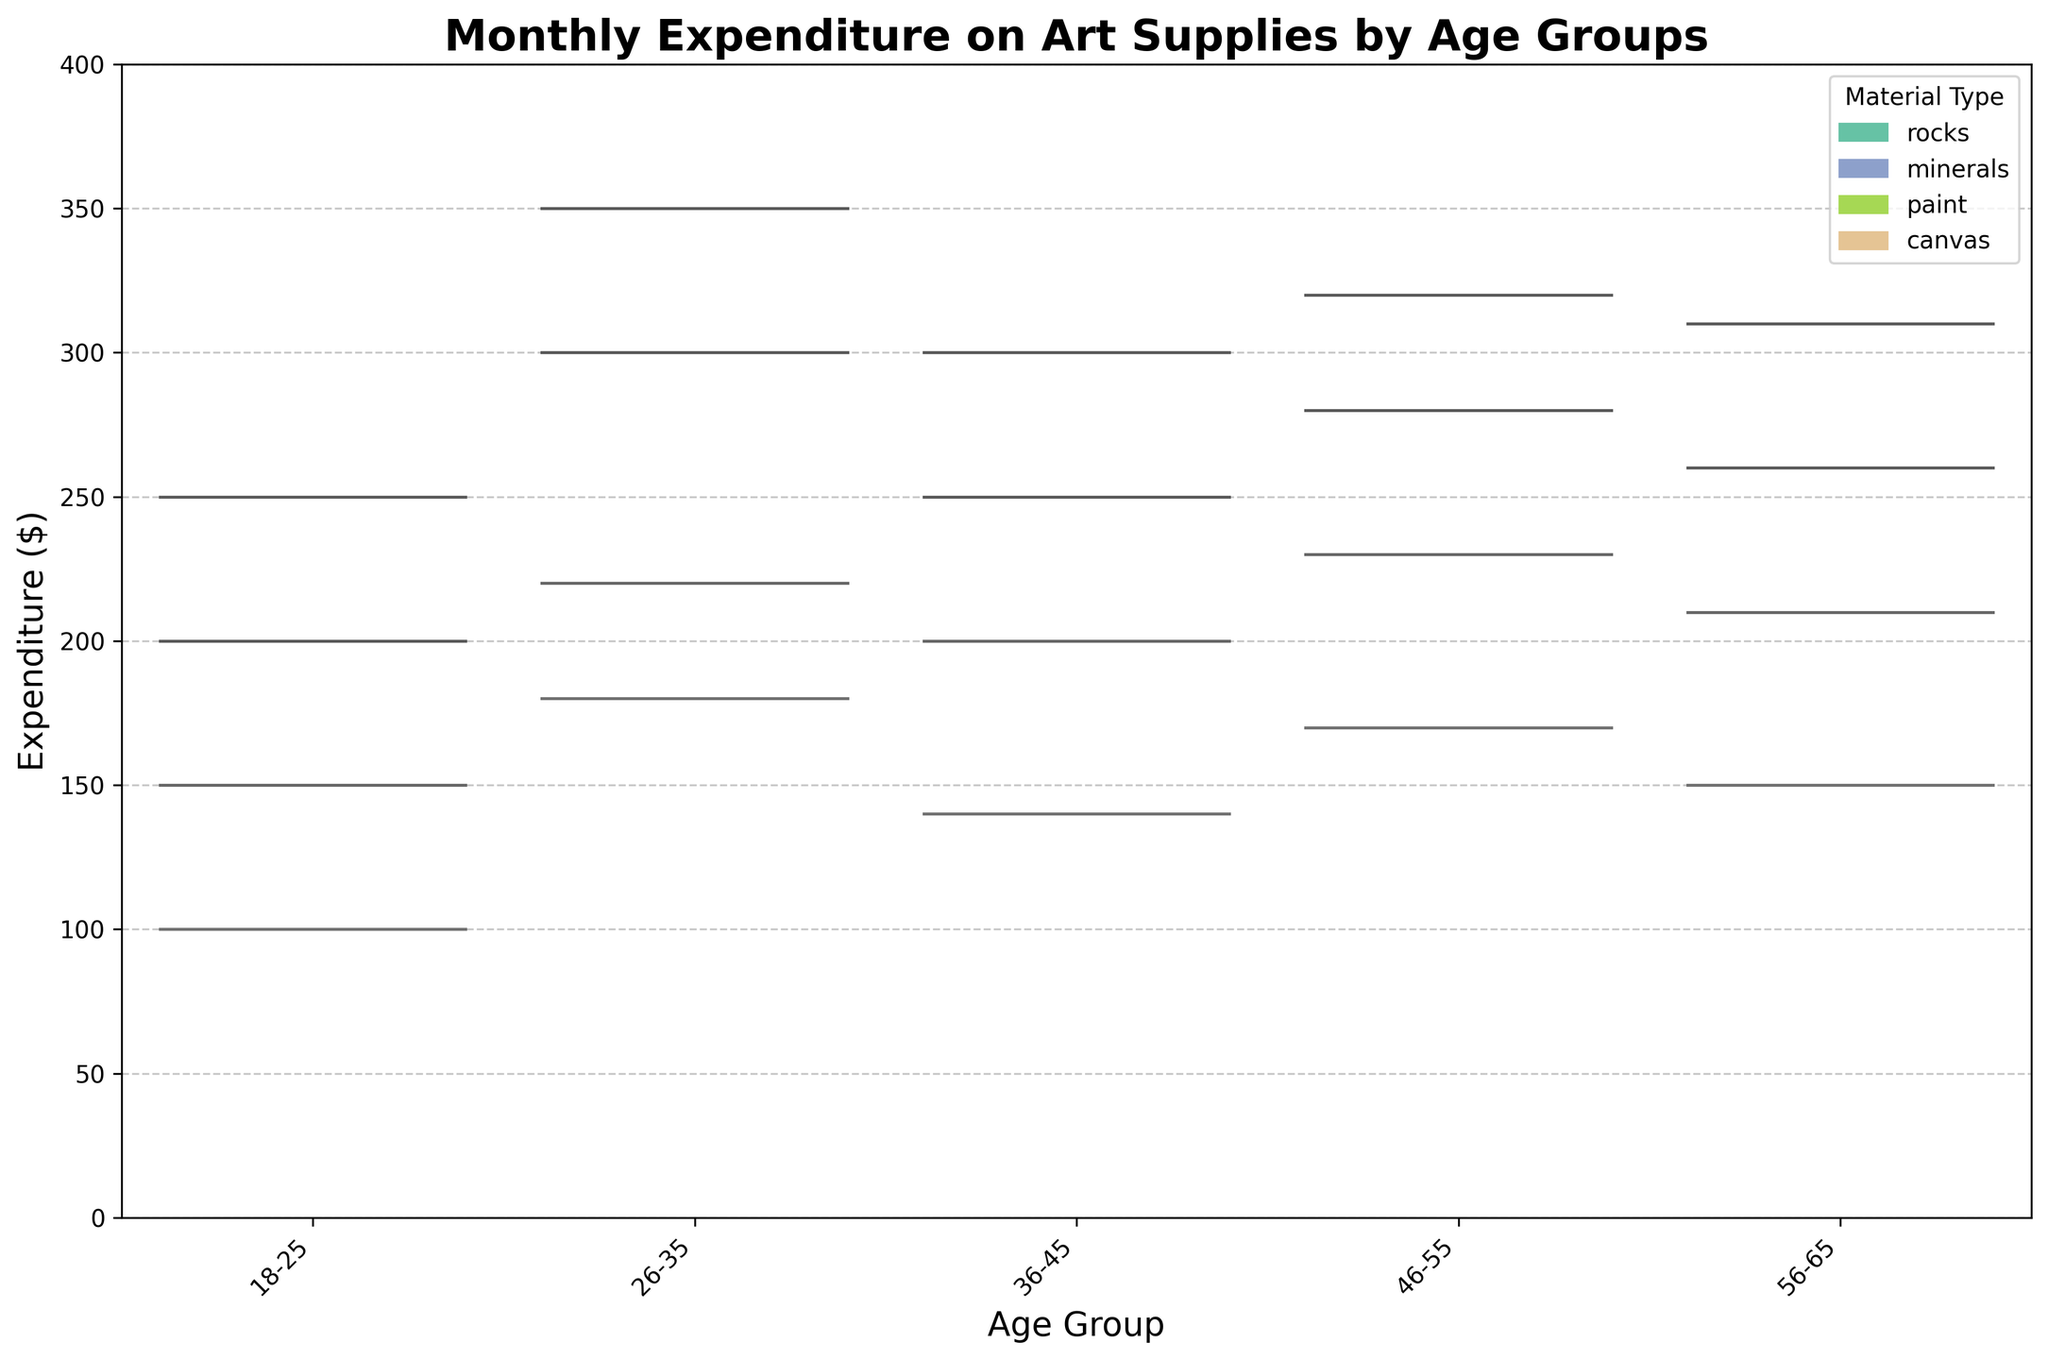What's the title of the figure? The title of the figure is usually located at the top and in this case, it mentions the main focus of the data which is 'Monthly Expenditure on Art Supplies by Age Groups'.
Answer: Monthly Expenditure on Art Supplies by Age Groups What is the y-axis label? The y-axis label is located to the side of the y-axis and denotes the metric being measured which, in this figure, is the amount spent.
Answer: Expenditure ($) Which age group has the highest expenditure on paint? By comparing the heights of the violin plots for paint in each age group, the 26-35 age group shows the highest expenditure.
Answer: 26-35 How does the expenditure on rocks compare between the 18-25 and 26-35 age groups? By examining the heights of the violin plots for rocks in these age groups, the plot for 26-35 is visibly higher than for 18-25, indicating higher expenditure.
Answer: 26-35 > 18-25 Which material type shows the widest range of expenditure in the 36-45 age group? Looking at the tops and bottoms of the violin plots for each material type within the 36-45 age group, paint has the widest range.
Answer: paint Do expenditures on minerals show a significant variation between age groups? By inspecting the spread of the violin plots for minerals across the age groups, there is a moderate range of expenditure indicating a variation without being overly extreme.
Answer: Moderate variation Is the expenditure on canvas higher for the 56-65 age group compared to the 46-55 age group? By visually comparing the heights of the violin plots for canvas, it appears slightly lower in the 56-65 age group in comparison to the 46-55 age group.
Answer: No What's the median expenditure on paint in the 46-55 age group? The median value is represented by the line inside the violin plot for paint within the 46-55 age group. Reading this value gives us the median expenditure.
Answer: ~$320 How do the expenditures on paint compare to the expenditures on canvas across all age groups? By examining the violin plots for paint and canvas, the paint expenditures are generally higher with larger and more spread distributions compared to the shorter and narrower distributions of canvas.
Answer: Paint > Canvas 